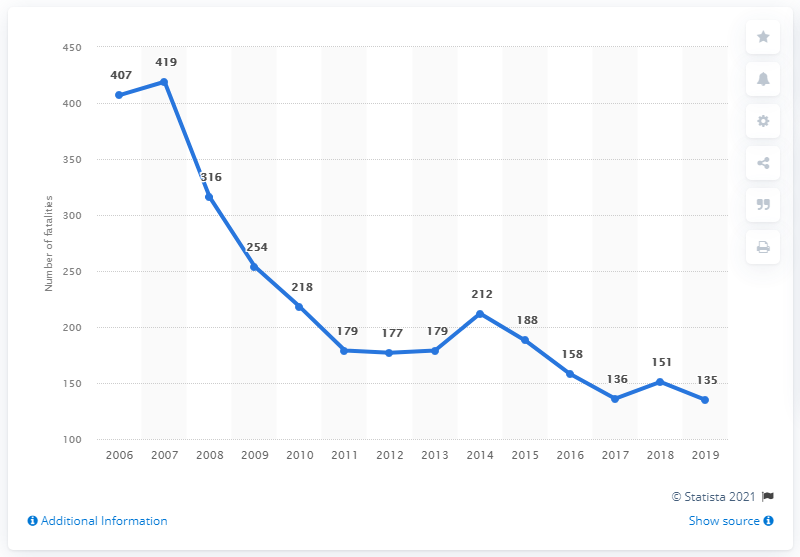What could be the reasons for the overall decline in road fatalities in Latvia seen in this graph? Several factors could contribute to the decline in road fatalities in Latvia as shown in the graph. These might include stricter traffic regulations, improved road safety measures, increased public awareness campaigns, enhancements in vehicle safety technology, and possibly fewer vehicles on the road during certain periods. 